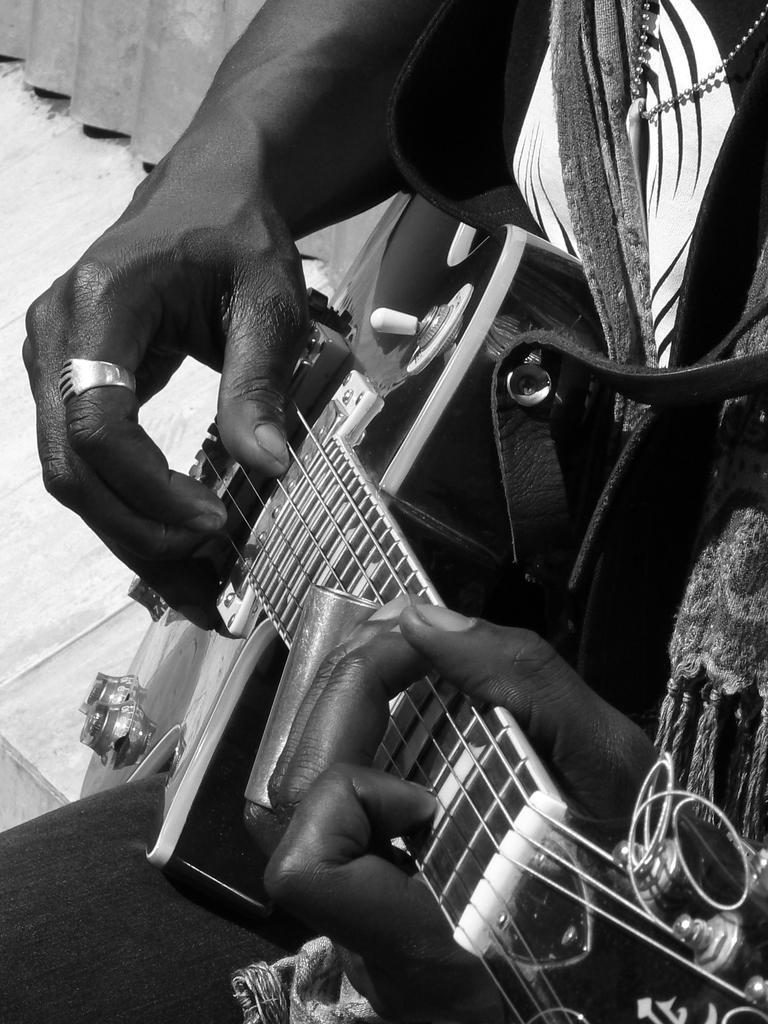Can you describe this image briefly? In this picture we can see hands of a person who is playing guitar. 